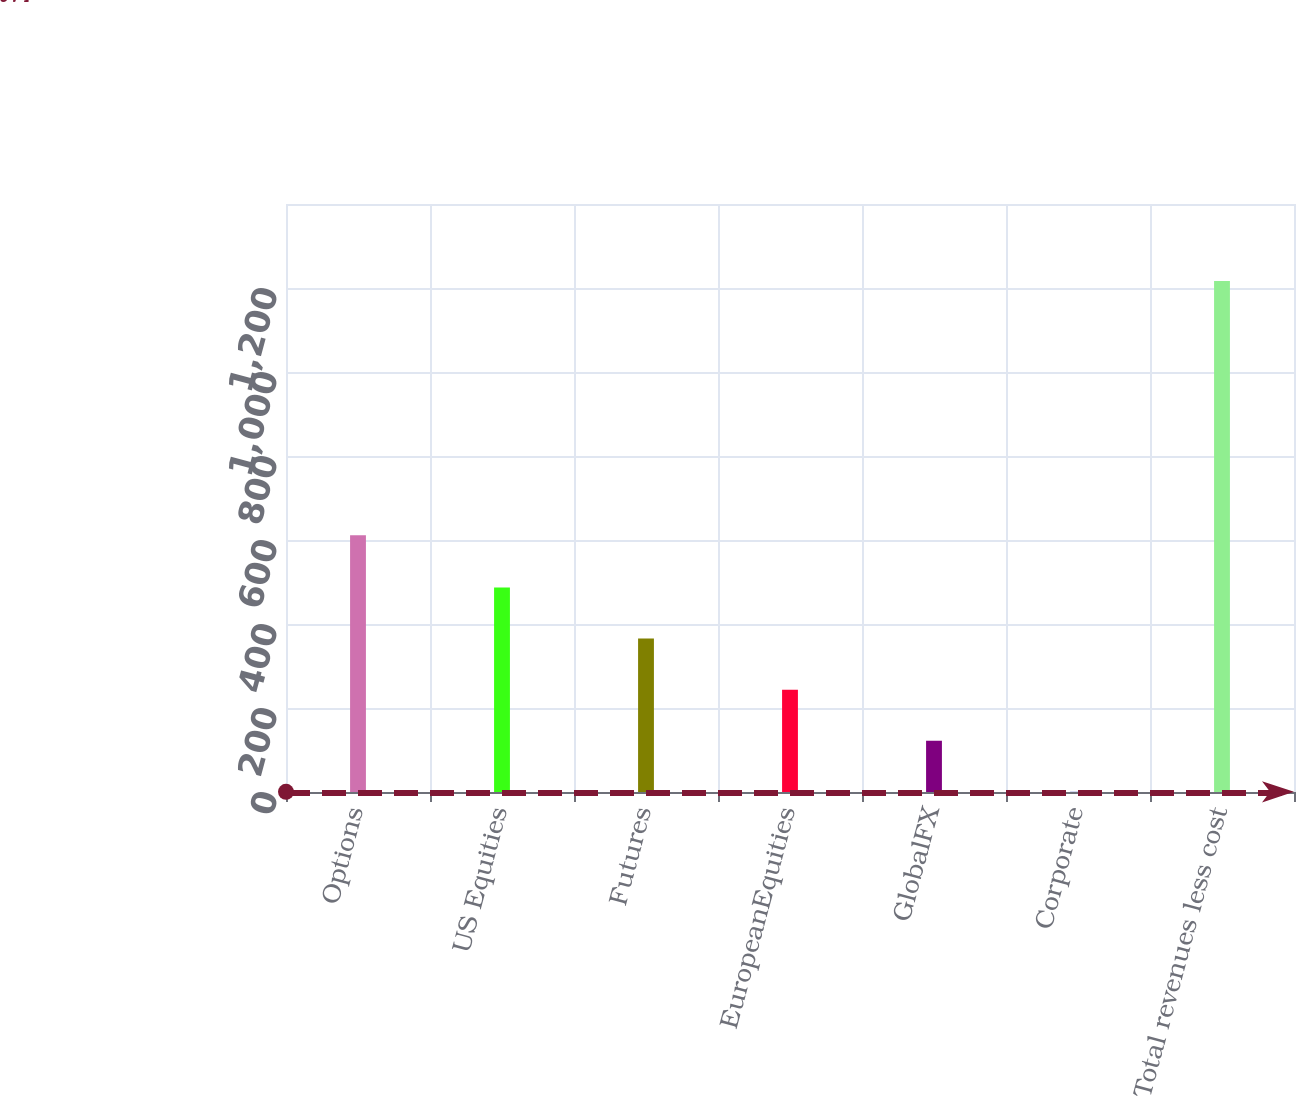<chart> <loc_0><loc_0><loc_500><loc_500><bar_chart><fcel>Options<fcel>US Equities<fcel>Futures<fcel>EuropeanEquities<fcel>GlobalFX<fcel>Corporate<fcel>Total revenues less cost<nl><fcel>611.2<fcel>487<fcel>365.35<fcel>243.7<fcel>122.05<fcel>0.4<fcel>1216.9<nl></chart> 